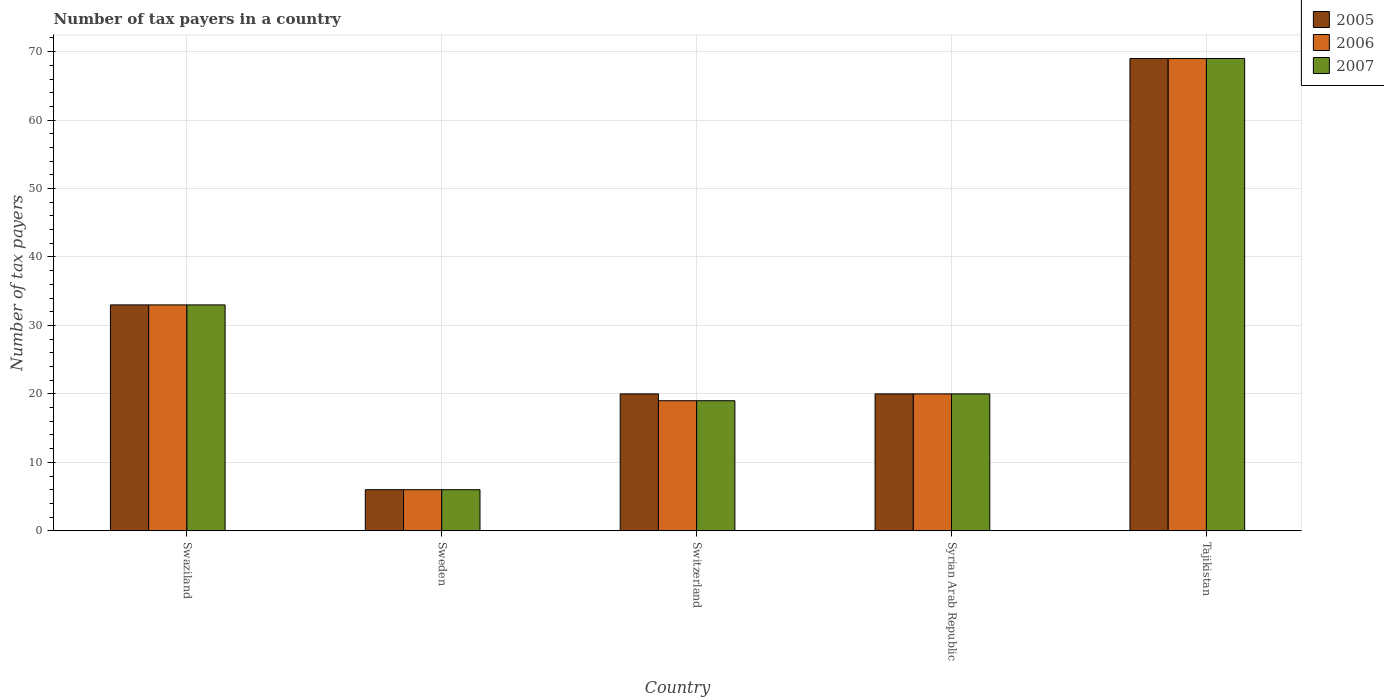How many different coloured bars are there?
Ensure brevity in your answer.  3. How many groups of bars are there?
Your answer should be very brief. 5. Are the number of bars per tick equal to the number of legend labels?
Keep it short and to the point. Yes. In how many cases, is the number of bars for a given country not equal to the number of legend labels?
Keep it short and to the point. 0. Across all countries, what is the maximum number of tax payers in in 2005?
Your response must be concise. 69. In which country was the number of tax payers in in 2007 maximum?
Ensure brevity in your answer.  Tajikistan. What is the total number of tax payers in in 2005 in the graph?
Your answer should be very brief. 148. What is the difference between the number of tax payers in in 2005 in Swaziland and that in Tajikistan?
Give a very brief answer. -36. What is the average number of tax payers in in 2006 per country?
Ensure brevity in your answer.  29.4. What is the difference between the number of tax payers in of/in 2005 and number of tax payers in of/in 2007 in Swaziland?
Your answer should be compact. 0. In how many countries, is the number of tax payers in in 2006 greater than the average number of tax payers in in 2006 taken over all countries?
Your response must be concise. 2. Is the sum of the number of tax payers in in 2006 in Swaziland and Switzerland greater than the maximum number of tax payers in in 2005 across all countries?
Offer a terse response. No. What does the 1st bar from the right in Sweden represents?
Ensure brevity in your answer.  2007. Is it the case that in every country, the sum of the number of tax payers in in 2007 and number of tax payers in in 2006 is greater than the number of tax payers in in 2005?
Offer a terse response. Yes. How many countries are there in the graph?
Make the answer very short. 5. What is the difference between two consecutive major ticks on the Y-axis?
Your response must be concise. 10. Does the graph contain any zero values?
Keep it short and to the point. No. Does the graph contain grids?
Keep it short and to the point. Yes. How are the legend labels stacked?
Your response must be concise. Vertical. What is the title of the graph?
Give a very brief answer. Number of tax payers in a country. What is the label or title of the X-axis?
Ensure brevity in your answer.  Country. What is the label or title of the Y-axis?
Your response must be concise. Number of tax payers. What is the Number of tax payers of 2006 in Swaziland?
Provide a succinct answer. 33. What is the Number of tax payers of 2007 in Swaziland?
Offer a very short reply. 33. What is the Number of tax payers in 2005 in Sweden?
Offer a very short reply. 6. What is the Number of tax payers in 2006 in Sweden?
Your answer should be compact. 6. What is the Number of tax payers of 2005 in Syrian Arab Republic?
Keep it short and to the point. 20. Across all countries, what is the minimum Number of tax payers of 2005?
Your answer should be compact. 6. Across all countries, what is the minimum Number of tax payers in 2006?
Give a very brief answer. 6. What is the total Number of tax payers of 2005 in the graph?
Your answer should be compact. 148. What is the total Number of tax payers of 2006 in the graph?
Give a very brief answer. 147. What is the total Number of tax payers of 2007 in the graph?
Your answer should be compact. 147. What is the difference between the Number of tax payers of 2005 in Swaziland and that in Sweden?
Keep it short and to the point. 27. What is the difference between the Number of tax payers in 2007 in Swaziland and that in Switzerland?
Ensure brevity in your answer.  14. What is the difference between the Number of tax payers of 2005 in Swaziland and that in Syrian Arab Republic?
Offer a terse response. 13. What is the difference between the Number of tax payers of 2007 in Swaziland and that in Syrian Arab Republic?
Offer a very short reply. 13. What is the difference between the Number of tax payers in 2005 in Swaziland and that in Tajikistan?
Your response must be concise. -36. What is the difference between the Number of tax payers of 2006 in Swaziland and that in Tajikistan?
Your response must be concise. -36. What is the difference between the Number of tax payers of 2007 in Swaziland and that in Tajikistan?
Offer a terse response. -36. What is the difference between the Number of tax payers in 2006 in Sweden and that in Switzerland?
Your answer should be very brief. -13. What is the difference between the Number of tax payers of 2007 in Sweden and that in Switzerland?
Give a very brief answer. -13. What is the difference between the Number of tax payers in 2006 in Sweden and that in Syrian Arab Republic?
Your response must be concise. -14. What is the difference between the Number of tax payers of 2005 in Sweden and that in Tajikistan?
Make the answer very short. -63. What is the difference between the Number of tax payers in 2006 in Sweden and that in Tajikistan?
Give a very brief answer. -63. What is the difference between the Number of tax payers in 2007 in Sweden and that in Tajikistan?
Offer a terse response. -63. What is the difference between the Number of tax payers of 2005 in Switzerland and that in Syrian Arab Republic?
Offer a very short reply. 0. What is the difference between the Number of tax payers of 2006 in Switzerland and that in Syrian Arab Republic?
Offer a terse response. -1. What is the difference between the Number of tax payers in 2007 in Switzerland and that in Syrian Arab Republic?
Your answer should be compact. -1. What is the difference between the Number of tax payers of 2005 in Switzerland and that in Tajikistan?
Make the answer very short. -49. What is the difference between the Number of tax payers of 2007 in Switzerland and that in Tajikistan?
Provide a short and direct response. -50. What is the difference between the Number of tax payers of 2005 in Syrian Arab Republic and that in Tajikistan?
Provide a short and direct response. -49. What is the difference between the Number of tax payers of 2006 in Syrian Arab Republic and that in Tajikistan?
Offer a terse response. -49. What is the difference between the Number of tax payers in 2007 in Syrian Arab Republic and that in Tajikistan?
Your response must be concise. -49. What is the difference between the Number of tax payers of 2005 in Swaziland and the Number of tax payers of 2007 in Sweden?
Provide a succinct answer. 27. What is the difference between the Number of tax payers of 2005 in Swaziland and the Number of tax payers of 2006 in Switzerland?
Ensure brevity in your answer.  14. What is the difference between the Number of tax payers of 2005 in Swaziland and the Number of tax payers of 2007 in Switzerland?
Ensure brevity in your answer.  14. What is the difference between the Number of tax payers of 2005 in Swaziland and the Number of tax payers of 2006 in Syrian Arab Republic?
Your answer should be compact. 13. What is the difference between the Number of tax payers in 2005 in Swaziland and the Number of tax payers in 2007 in Syrian Arab Republic?
Offer a very short reply. 13. What is the difference between the Number of tax payers in 2005 in Swaziland and the Number of tax payers in 2006 in Tajikistan?
Offer a terse response. -36. What is the difference between the Number of tax payers of 2005 in Swaziland and the Number of tax payers of 2007 in Tajikistan?
Offer a very short reply. -36. What is the difference between the Number of tax payers in 2006 in Swaziland and the Number of tax payers in 2007 in Tajikistan?
Offer a very short reply. -36. What is the difference between the Number of tax payers in 2005 in Sweden and the Number of tax payers in 2006 in Switzerland?
Keep it short and to the point. -13. What is the difference between the Number of tax payers in 2005 in Sweden and the Number of tax payers in 2007 in Syrian Arab Republic?
Your answer should be compact. -14. What is the difference between the Number of tax payers in 2005 in Sweden and the Number of tax payers in 2006 in Tajikistan?
Your answer should be very brief. -63. What is the difference between the Number of tax payers of 2005 in Sweden and the Number of tax payers of 2007 in Tajikistan?
Give a very brief answer. -63. What is the difference between the Number of tax payers of 2006 in Sweden and the Number of tax payers of 2007 in Tajikistan?
Your answer should be compact. -63. What is the difference between the Number of tax payers in 2005 in Switzerland and the Number of tax payers in 2006 in Syrian Arab Republic?
Your response must be concise. 0. What is the difference between the Number of tax payers in 2006 in Switzerland and the Number of tax payers in 2007 in Syrian Arab Republic?
Keep it short and to the point. -1. What is the difference between the Number of tax payers in 2005 in Switzerland and the Number of tax payers in 2006 in Tajikistan?
Your response must be concise. -49. What is the difference between the Number of tax payers in 2005 in Switzerland and the Number of tax payers in 2007 in Tajikistan?
Keep it short and to the point. -49. What is the difference between the Number of tax payers in 2006 in Switzerland and the Number of tax payers in 2007 in Tajikistan?
Your response must be concise. -50. What is the difference between the Number of tax payers in 2005 in Syrian Arab Republic and the Number of tax payers in 2006 in Tajikistan?
Your answer should be very brief. -49. What is the difference between the Number of tax payers of 2005 in Syrian Arab Republic and the Number of tax payers of 2007 in Tajikistan?
Offer a very short reply. -49. What is the difference between the Number of tax payers of 2006 in Syrian Arab Republic and the Number of tax payers of 2007 in Tajikistan?
Give a very brief answer. -49. What is the average Number of tax payers of 2005 per country?
Ensure brevity in your answer.  29.6. What is the average Number of tax payers in 2006 per country?
Provide a succinct answer. 29.4. What is the average Number of tax payers of 2007 per country?
Offer a very short reply. 29.4. What is the difference between the Number of tax payers of 2005 and Number of tax payers of 2006 in Swaziland?
Give a very brief answer. 0. What is the difference between the Number of tax payers of 2005 and Number of tax payers of 2006 in Sweden?
Ensure brevity in your answer.  0. What is the difference between the Number of tax payers of 2006 and Number of tax payers of 2007 in Sweden?
Your answer should be compact. 0. What is the difference between the Number of tax payers of 2006 and Number of tax payers of 2007 in Switzerland?
Offer a terse response. 0. What is the difference between the Number of tax payers of 2005 and Number of tax payers of 2007 in Tajikistan?
Offer a very short reply. 0. What is the ratio of the Number of tax payers of 2006 in Swaziland to that in Sweden?
Give a very brief answer. 5.5. What is the ratio of the Number of tax payers in 2005 in Swaziland to that in Switzerland?
Your answer should be very brief. 1.65. What is the ratio of the Number of tax payers in 2006 in Swaziland to that in Switzerland?
Ensure brevity in your answer.  1.74. What is the ratio of the Number of tax payers of 2007 in Swaziland to that in Switzerland?
Give a very brief answer. 1.74. What is the ratio of the Number of tax payers in 2005 in Swaziland to that in Syrian Arab Republic?
Give a very brief answer. 1.65. What is the ratio of the Number of tax payers of 2006 in Swaziland to that in Syrian Arab Republic?
Your answer should be compact. 1.65. What is the ratio of the Number of tax payers in 2007 in Swaziland to that in Syrian Arab Republic?
Your answer should be very brief. 1.65. What is the ratio of the Number of tax payers of 2005 in Swaziland to that in Tajikistan?
Your response must be concise. 0.48. What is the ratio of the Number of tax payers of 2006 in Swaziland to that in Tajikistan?
Provide a short and direct response. 0.48. What is the ratio of the Number of tax payers of 2007 in Swaziland to that in Tajikistan?
Provide a succinct answer. 0.48. What is the ratio of the Number of tax payers in 2005 in Sweden to that in Switzerland?
Make the answer very short. 0.3. What is the ratio of the Number of tax payers of 2006 in Sweden to that in Switzerland?
Provide a short and direct response. 0.32. What is the ratio of the Number of tax payers of 2007 in Sweden to that in Switzerland?
Provide a short and direct response. 0.32. What is the ratio of the Number of tax payers of 2007 in Sweden to that in Syrian Arab Republic?
Give a very brief answer. 0.3. What is the ratio of the Number of tax payers in 2005 in Sweden to that in Tajikistan?
Provide a succinct answer. 0.09. What is the ratio of the Number of tax payers of 2006 in Sweden to that in Tajikistan?
Provide a succinct answer. 0.09. What is the ratio of the Number of tax payers in 2007 in Sweden to that in Tajikistan?
Your answer should be very brief. 0.09. What is the ratio of the Number of tax payers in 2006 in Switzerland to that in Syrian Arab Republic?
Keep it short and to the point. 0.95. What is the ratio of the Number of tax payers of 2007 in Switzerland to that in Syrian Arab Republic?
Keep it short and to the point. 0.95. What is the ratio of the Number of tax payers of 2005 in Switzerland to that in Tajikistan?
Ensure brevity in your answer.  0.29. What is the ratio of the Number of tax payers of 2006 in Switzerland to that in Tajikistan?
Your answer should be very brief. 0.28. What is the ratio of the Number of tax payers in 2007 in Switzerland to that in Tajikistan?
Provide a short and direct response. 0.28. What is the ratio of the Number of tax payers of 2005 in Syrian Arab Republic to that in Tajikistan?
Provide a succinct answer. 0.29. What is the ratio of the Number of tax payers of 2006 in Syrian Arab Republic to that in Tajikistan?
Your answer should be very brief. 0.29. What is the ratio of the Number of tax payers of 2007 in Syrian Arab Republic to that in Tajikistan?
Your response must be concise. 0.29. What is the difference between the highest and the second highest Number of tax payers of 2006?
Make the answer very short. 36. What is the difference between the highest and the second highest Number of tax payers of 2007?
Your answer should be compact. 36. What is the difference between the highest and the lowest Number of tax payers in 2005?
Keep it short and to the point. 63. What is the difference between the highest and the lowest Number of tax payers in 2006?
Your response must be concise. 63. What is the difference between the highest and the lowest Number of tax payers in 2007?
Your answer should be very brief. 63. 